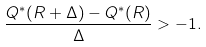<formula> <loc_0><loc_0><loc_500><loc_500>\frac { Q ^ { * } ( R + \Delta ) - Q ^ { * } ( R ) } { \Delta } > - 1 .</formula> 